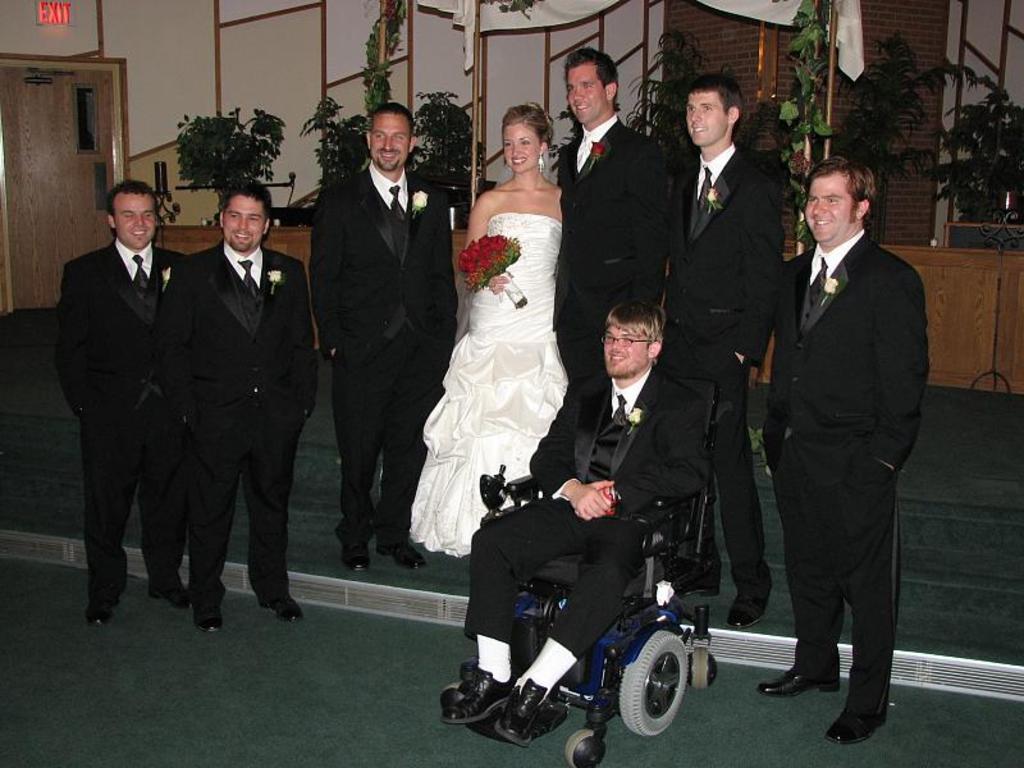In one or two sentences, can you explain what this image depicts? In the image we can see there are people standing and there is a woman holding rose flower bouquet in her hand. There is a person sitting on the wheel chair and behind there are plants kept in the pots. There is an exit sign board on the wall. 